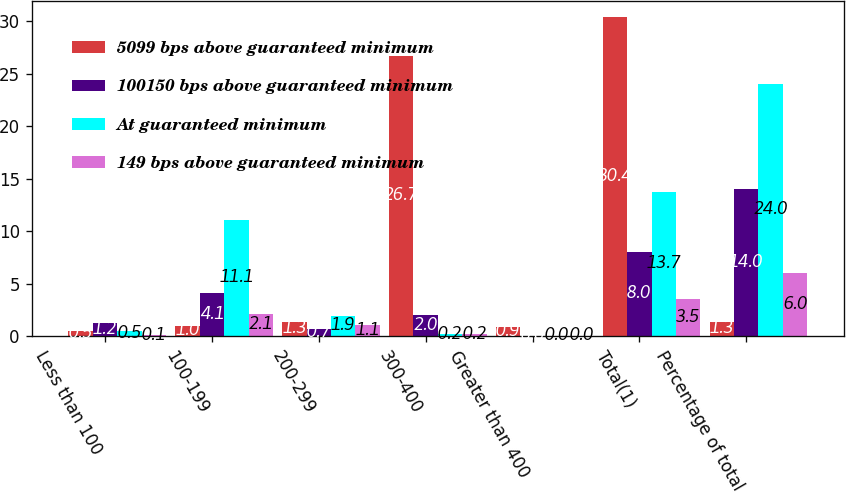Convert chart. <chart><loc_0><loc_0><loc_500><loc_500><stacked_bar_chart><ecel><fcel>Less than 100<fcel>100-199<fcel>200-299<fcel>300-400<fcel>Greater than 400<fcel>Total(1)<fcel>Percentage of total<nl><fcel>5099 bps above guaranteed minimum<fcel>0.5<fcel>1<fcel>1.3<fcel>26.7<fcel>0.9<fcel>30.4<fcel>1.3<nl><fcel>100150 bps above guaranteed minimum<fcel>1.2<fcel>4.1<fcel>0.7<fcel>2<fcel>0<fcel>8<fcel>14<nl><fcel>At guaranteed minimum<fcel>0.5<fcel>11.1<fcel>1.9<fcel>0.2<fcel>0<fcel>13.7<fcel>24<nl><fcel>149 bps above guaranteed minimum<fcel>0.1<fcel>2.1<fcel>1.1<fcel>0.2<fcel>0<fcel>3.5<fcel>6<nl></chart> 